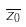<formula> <loc_0><loc_0><loc_500><loc_500>\overline { z _ { 0 } }</formula> 